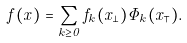Convert formula to latex. <formula><loc_0><loc_0><loc_500><loc_500>f ( x ) = \sum _ { k \geq 0 } f _ { k } ( x _ { \perp } ) \Phi _ { k } ( x _ { \intercal } ) .</formula> 